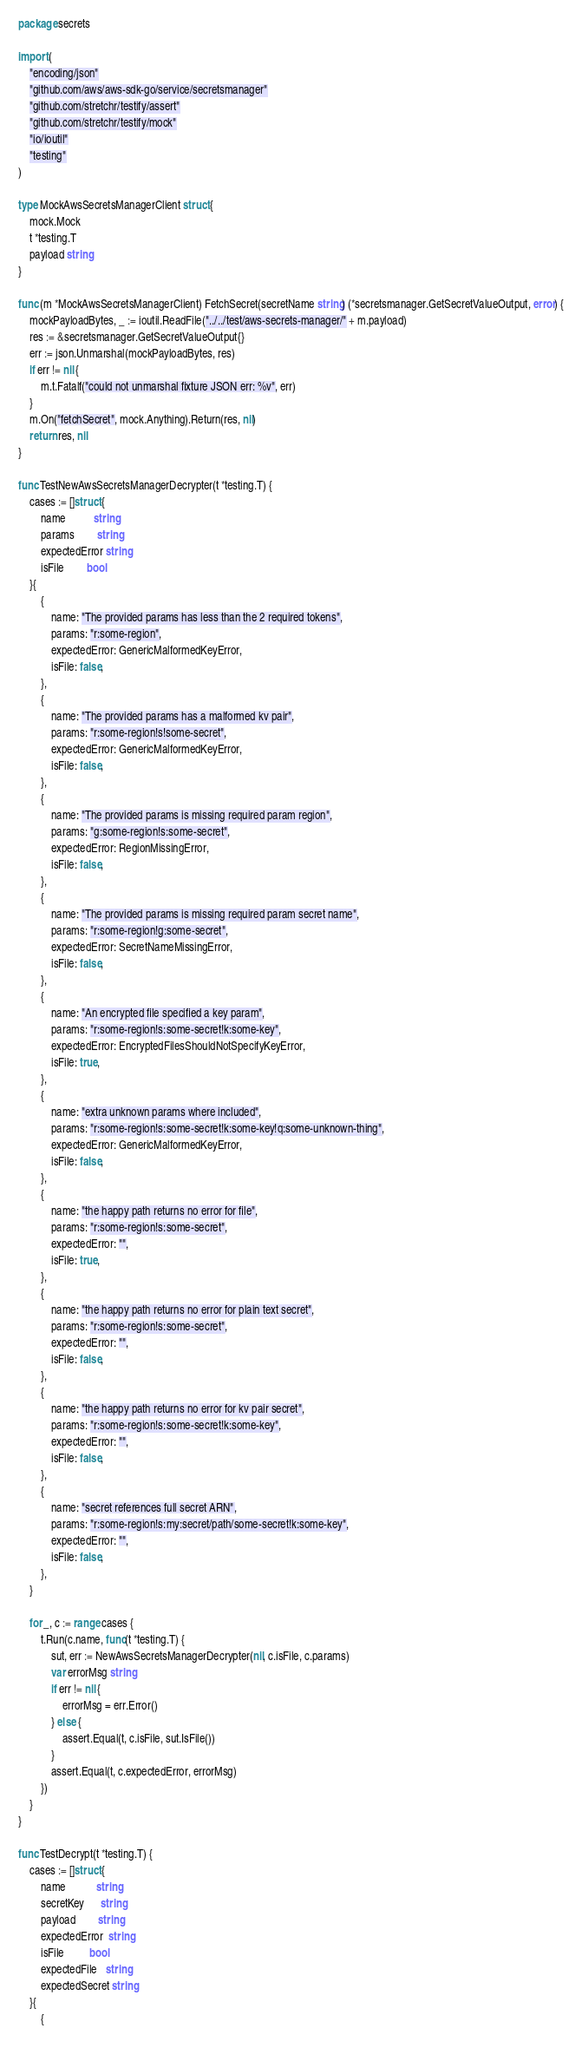Convert code to text. <code><loc_0><loc_0><loc_500><loc_500><_Go_>package secrets

import (
	"encoding/json"
	"github.com/aws/aws-sdk-go/service/secretsmanager"
	"github.com/stretchr/testify/assert"
	"github.com/stretchr/testify/mock"
	"io/ioutil"
	"testing"
)

type MockAwsSecretsManagerClient struct {
	mock.Mock
	t *testing.T
	payload string
}

func (m *MockAwsSecretsManagerClient) FetchSecret(secretName string) (*secretsmanager.GetSecretValueOutput, error) {
	mockPayloadBytes, _ := ioutil.ReadFile("../../test/aws-secrets-manager/" + m.payload)
	res := &secretsmanager.GetSecretValueOutput{}
	err := json.Unmarshal(mockPayloadBytes, res)
	if err != nil {
		m.t.Fatalf("could not unmarshal fixture JSON err: %v", err)
	}
	m.On("fetchSecret", mock.Anything).Return(res, nil)
	return res, nil
}

func TestNewAwsSecretsManagerDecrypter(t *testing.T) {
	cases := []struct {
		name          string
		params        string
		expectedError string
		isFile        bool
	}{
		{
			name: "The provided params has less than the 2 required tokens",
			params: "r:some-region",
			expectedError: GenericMalformedKeyError,
			isFile: false,
		},
		{
			name: "The provided params has a malformed kv pair",
			params: "r:some-region!s!some-secret",
			expectedError: GenericMalformedKeyError,
			isFile: false,
		},
		{
			name: "The provided params is missing required param region",
			params: "g:some-region!s:some-secret",
			expectedError: RegionMissingError,
			isFile: false,
		},
		{
			name: "The provided params is missing required param secret name",
			params: "r:some-region!g:some-secret",
			expectedError: SecretNameMissingError,
			isFile: false,
		},
		{
			name: "An encrypted file specified a key param",
			params: "r:some-region!s:some-secret!k:some-key",
			expectedError: EncryptedFilesShouldNotSpecifyKeyError,
			isFile: true,
		},
		{
			name: "extra unknown params where included",
			params: "r:some-region!s:some-secret!k:some-key!q:some-unknown-thing",
			expectedError: GenericMalformedKeyError,
			isFile: false,
		},
		{
			name: "the happy path returns no error for file",
			params: "r:some-region!s:some-secret",
			expectedError: "",
			isFile: true,
		},
		{
			name: "the happy path returns no error for plain text secret",
			params: "r:some-region!s:some-secret",
			expectedError: "",
			isFile: false,
		},
		{
			name: "the happy path returns no error for kv pair secret",
			params: "r:some-region!s:some-secret!k:some-key",
			expectedError: "",
			isFile: false,
		},
		{
			name: "secret references full secret ARN",
			params: "r:some-region!s:my:secret/path/some-secret!k:some-key",
			expectedError: "",
			isFile: false,
		},
	}

	for _, c := range cases {
		t.Run(c.name, func(t *testing.T) {
			sut, err := NewAwsSecretsManagerDecrypter(nil, c.isFile, c.params)
			var errorMsg string
			if err != nil {
				errorMsg = err.Error()
			} else {
				assert.Equal(t, c.isFile, sut.IsFile())
			}
			assert.Equal(t, c.expectedError, errorMsg)
		})
	}
}

func TestDecrypt(t *testing.T) {
	cases := []struct {
		name           string
		secretKey      string
		payload        string
		expectedError  string
		isFile         bool
		expectedFile   string
		expectedSecret string
	}{
		{</code> 